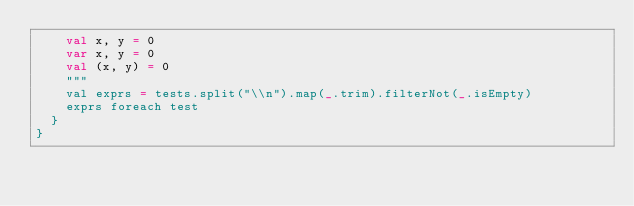<code> <loc_0><loc_0><loc_500><loc_500><_Scala_>    val x, y = 0
    var x, y = 0
    val (x, y) = 0
    """
    val exprs = tests.split("\\n").map(_.trim).filterNot(_.isEmpty)
    exprs foreach test
  }
}
</code> 